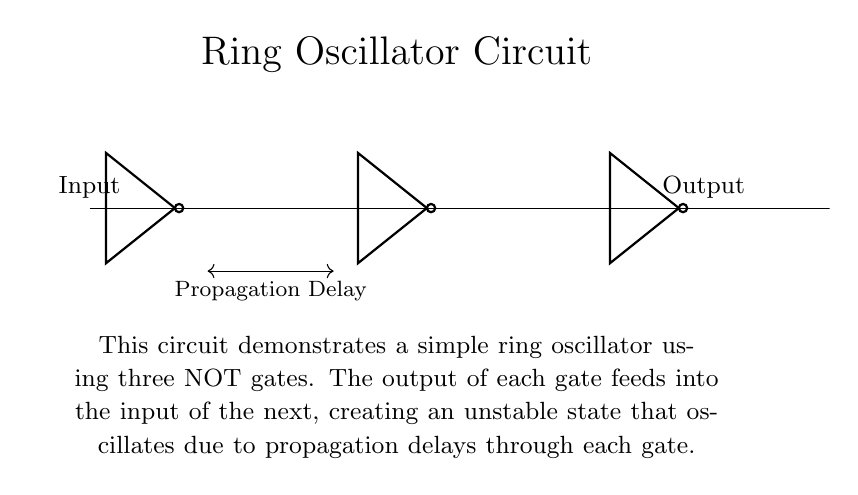What components are used in the circuit? The circuit consists of three NOT gates connected in series, which are the fundamental components that create the oscillation.
Answer: three NOT gates What is the output of the ring oscillator? The output is the signal that oscillates continuously due to the feedback from the last NOT gate to the first, resulting in a square wave.
Answer: oscillating signal How many propagation delays are present in this circuit? There are three propagation delays, one from each NOT gate. They accumulate as the signal travels through the circuit.
Answer: three What is the function of the feedback loop in this circuit? The feedback loop connects the output of the last NOT gate to the input of the first, enabling continuous oscillation by regenerating the signal.
Answer: continuous oscillation What type of signal do ring oscillators typically produce? Ring oscillators usually produce a periodic digital square wave, alternating between high and low states.
Answer: square wave How does the number of NOT gates affect the oscillation frequency? The frequency of oscillation is inversely proportional to the number of gates; increasing the number of gates lowers the frequency since it takes longer for the signal to propagate through all components.
Answer: lowers frequency 